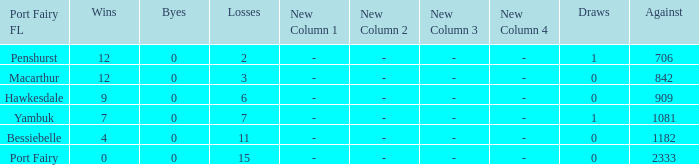How many draws when the Port Fairy FL is Hawkesdale and there are more than 9 wins? None. 